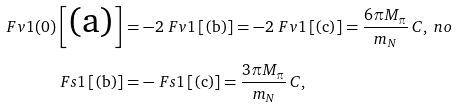Convert formula to latex. <formula><loc_0><loc_0><loc_500><loc_500>\ F v { 1 } ( 0 ) \left [ \text {(a)} \right ] & = - 2 \ F v { 1 } \left [ \text {(b)} \right ] = - 2 \ F v { 1 } \left [ \text {(c)} \right ] = \frac { 6 \pi M _ { \pi } } { m _ { N } } \, C , \ n o \\ \ F s { 1 } \left [ \text {(b)} \right ] & = - \ F s { 1 } \left [ \text {(c)} \right ] = \frac { 3 \pi M _ { \pi } } { m _ { N } } \, C ,</formula> 